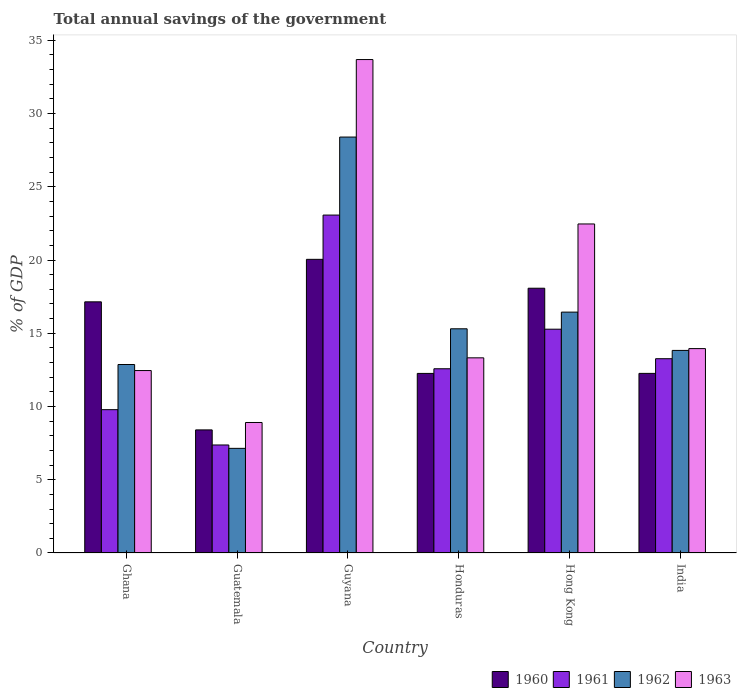How many different coloured bars are there?
Provide a short and direct response. 4. How many groups of bars are there?
Provide a short and direct response. 6. Are the number of bars on each tick of the X-axis equal?
Give a very brief answer. Yes. How many bars are there on the 6th tick from the left?
Provide a short and direct response. 4. What is the label of the 4th group of bars from the left?
Keep it short and to the point. Honduras. In how many cases, is the number of bars for a given country not equal to the number of legend labels?
Provide a short and direct response. 0. What is the total annual savings of the government in 1963 in Guyana?
Your answer should be compact. 33.69. Across all countries, what is the maximum total annual savings of the government in 1961?
Provide a short and direct response. 23.07. Across all countries, what is the minimum total annual savings of the government in 1963?
Give a very brief answer. 8.91. In which country was the total annual savings of the government in 1962 maximum?
Make the answer very short. Guyana. In which country was the total annual savings of the government in 1962 minimum?
Make the answer very short. Guatemala. What is the total total annual savings of the government in 1961 in the graph?
Your response must be concise. 81.35. What is the difference between the total annual savings of the government in 1962 in Hong Kong and that in India?
Your response must be concise. 2.61. What is the difference between the total annual savings of the government in 1963 in Hong Kong and the total annual savings of the government in 1962 in India?
Ensure brevity in your answer.  8.63. What is the average total annual savings of the government in 1963 per country?
Provide a succinct answer. 17.47. What is the difference between the total annual savings of the government of/in 1960 and total annual savings of the government of/in 1963 in Guatemala?
Provide a succinct answer. -0.51. In how many countries, is the total annual savings of the government in 1960 greater than 5 %?
Your answer should be compact. 6. What is the ratio of the total annual savings of the government in 1963 in Honduras to that in Hong Kong?
Provide a succinct answer. 0.59. Is the total annual savings of the government in 1960 in Ghana less than that in India?
Give a very brief answer. No. What is the difference between the highest and the second highest total annual savings of the government in 1960?
Provide a short and direct response. -0.93. What is the difference between the highest and the lowest total annual savings of the government in 1960?
Ensure brevity in your answer.  11.64. In how many countries, is the total annual savings of the government in 1960 greater than the average total annual savings of the government in 1960 taken over all countries?
Your response must be concise. 3. Is the sum of the total annual savings of the government in 1963 in Ghana and India greater than the maximum total annual savings of the government in 1961 across all countries?
Your response must be concise. Yes. What does the 3rd bar from the left in Honduras represents?
Your response must be concise. 1962. What does the 1st bar from the right in Hong Kong represents?
Your answer should be very brief. 1963. Is it the case that in every country, the sum of the total annual savings of the government in 1961 and total annual savings of the government in 1960 is greater than the total annual savings of the government in 1962?
Make the answer very short. Yes. How many bars are there?
Provide a succinct answer. 24. Are all the bars in the graph horizontal?
Provide a short and direct response. No. How many countries are there in the graph?
Your answer should be compact. 6. What is the difference between two consecutive major ticks on the Y-axis?
Provide a succinct answer. 5. Are the values on the major ticks of Y-axis written in scientific E-notation?
Ensure brevity in your answer.  No. Does the graph contain any zero values?
Keep it short and to the point. No. Does the graph contain grids?
Make the answer very short. No. How are the legend labels stacked?
Your answer should be very brief. Horizontal. What is the title of the graph?
Keep it short and to the point. Total annual savings of the government. Does "1989" appear as one of the legend labels in the graph?
Make the answer very short. No. What is the label or title of the X-axis?
Ensure brevity in your answer.  Country. What is the label or title of the Y-axis?
Ensure brevity in your answer.  % of GDP. What is the % of GDP in 1960 in Ghana?
Offer a terse response. 17.15. What is the % of GDP of 1961 in Ghana?
Ensure brevity in your answer.  9.78. What is the % of GDP in 1962 in Ghana?
Keep it short and to the point. 12.87. What is the % of GDP of 1963 in Ghana?
Your response must be concise. 12.45. What is the % of GDP in 1960 in Guatemala?
Your answer should be compact. 8.4. What is the % of GDP of 1961 in Guatemala?
Ensure brevity in your answer.  7.37. What is the % of GDP in 1962 in Guatemala?
Keep it short and to the point. 7.14. What is the % of GDP of 1963 in Guatemala?
Offer a very short reply. 8.91. What is the % of GDP in 1960 in Guyana?
Ensure brevity in your answer.  20.05. What is the % of GDP in 1961 in Guyana?
Your answer should be very brief. 23.07. What is the % of GDP of 1962 in Guyana?
Provide a succinct answer. 28.4. What is the % of GDP of 1963 in Guyana?
Ensure brevity in your answer.  33.69. What is the % of GDP in 1960 in Honduras?
Your answer should be compact. 12.26. What is the % of GDP in 1961 in Honduras?
Ensure brevity in your answer.  12.58. What is the % of GDP of 1962 in Honduras?
Make the answer very short. 15.31. What is the % of GDP of 1963 in Honduras?
Your answer should be very brief. 13.32. What is the % of GDP of 1960 in Hong Kong?
Provide a succinct answer. 18.07. What is the % of GDP of 1961 in Hong Kong?
Keep it short and to the point. 15.28. What is the % of GDP in 1962 in Hong Kong?
Your answer should be compact. 16.44. What is the % of GDP in 1963 in Hong Kong?
Ensure brevity in your answer.  22.46. What is the % of GDP of 1960 in India?
Offer a very short reply. 12.26. What is the % of GDP of 1961 in India?
Offer a terse response. 13.26. What is the % of GDP of 1962 in India?
Ensure brevity in your answer.  13.83. What is the % of GDP of 1963 in India?
Ensure brevity in your answer.  13.95. Across all countries, what is the maximum % of GDP of 1960?
Offer a very short reply. 20.05. Across all countries, what is the maximum % of GDP of 1961?
Make the answer very short. 23.07. Across all countries, what is the maximum % of GDP of 1962?
Make the answer very short. 28.4. Across all countries, what is the maximum % of GDP of 1963?
Offer a terse response. 33.69. Across all countries, what is the minimum % of GDP in 1960?
Provide a short and direct response. 8.4. Across all countries, what is the minimum % of GDP in 1961?
Offer a very short reply. 7.37. Across all countries, what is the minimum % of GDP in 1962?
Provide a short and direct response. 7.14. Across all countries, what is the minimum % of GDP of 1963?
Give a very brief answer. 8.91. What is the total % of GDP of 1960 in the graph?
Offer a very short reply. 88.19. What is the total % of GDP of 1961 in the graph?
Give a very brief answer. 81.35. What is the total % of GDP of 1962 in the graph?
Ensure brevity in your answer.  93.99. What is the total % of GDP of 1963 in the graph?
Your response must be concise. 104.79. What is the difference between the % of GDP in 1960 in Ghana and that in Guatemala?
Provide a short and direct response. 8.74. What is the difference between the % of GDP in 1961 in Ghana and that in Guatemala?
Make the answer very short. 2.41. What is the difference between the % of GDP in 1962 in Ghana and that in Guatemala?
Ensure brevity in your answer.  5.72. What is the difference between the % of GDP of 1963 in Ghana and that in Guatemala?
Your answer should be compact. 3.55. What is the difference between the % of GDP in 1960 in Ghana and that in Guyana?
Your answer should be very brief. -2.9. What is the difference between the % of GDP in 1961 in Ghana and that in Guyana?
Your response must be concise. -13.28. What is the difference between the % of GDP in 1962 in Ghana and that in Guyana?
Keep it short and to the point. -15.53. What is the difference between the % of GDP of 1963 in Ghana and that in Guyana?
Make the answer very short. -21.23. What is the difference between the % of GDP of 1960 in Ghana and that in Honduras?
Ensure brevity in your answer.  4.89. What is the difference between the % of GDP in 1961 in Ghana and that in Honduras?
Offer a terse response. -2.79. What is the difference between the % of GDP in 1962 in Ghana and that in Honduras?
Ensure brevity in your answer.  -2.44. What is the difference between the % of GDP of 1963 in Ghana and that in Honduras?
Your answer should be very brief. -0.87. What is the difference between the % of GDP of 1960 in Ghana and that in Hong Kong?
Your answer should be very brief. -0.93. What is the difference between the % of GDP of 1961 in Ghana and that in Hong Kong?
Give a very brief answer. -5.49. What is the difference between the % of GDP in 1962 in Ghana and that in Hong Kong?
Keep it short and to the point. -3.58. What is the difference between the % of GDP of 1963 in Ghana and that in Hong Kong?
Ensure brevity in your answer.  -10.01. What is the difference between the % of GDP of 1960 in Ghana and that in India?
Provide a short and direct response. 4.88. What is the difference between the % of GDP in 1961 in Ghana and that in India?
Offer a very short reply. -3.48. What is the difference between the % of GDP of 1962 in Ghana and that in India?
Make the answer very short. -0.96. What is the difference between the % of GDP of 1963 in Ghana and that in India?
Your answer should be very brief. -1.5. What is the difference between the % of GDP of 1960 in Guatemala and that in Guyana?
Your answer should be very brief. -11.64. What is the difference between the % of GDP of 1961 in Guatemala and that in Guyana?
Give a very brief answer. -15.7. What is the difference between the % of GDP in 1962 in Guatemala and that in Guyana?
Ensure brevity in your answer.  -21.25. What is the difference between the % of GDP in 1963 in Guatemala and that in Guyana?
Keep it short and to the point. -24.78. What is the difference between the % of GDP of 1960 in Guatemala and that in Honduras?
Your response must be concise. -3.86. What is the difference between the % of GDP of 1961 in Guatemala and that in Honduras?
Provide a short and direct response. -5.2. What is the difference between the % of GDP in 1962 in Guatemala and that in Honduras?
Offer a terse response. -8.16. What is the difference between the % of GDP of 1963 in Guatemala and that in Honduras?
Give a very brief answer. -4.41. What is the difference between the % of GDP of 1960 in Guatemala and that in Hong Kong?
Keep it short and to the point. -9.67. What is the difference between the % of GDP in 1961 in Guatemala and that in Hong Kong?
Your answer should be compact. -7.9. What is the difference between the % of GDP in 1962 in Guatemala and that in Hong Kong?
Your answer should be very brief. -9.3. What is the difference between the % of GDP in 1963 in Guatemala and that in Hong Kong?
Your response must be concise. -13.55. What is the difference between the % of GDP of 1960 in Guatemala and that in India?
Your answer should be compact. -3.86. What is the difference between the % of GDP of 1961 in Guatemala and that in India?
Ensure brevity in your answer.  -5.89. What is the difference between the % of GDP in 1962 in Guatemala and that in India?
Your answer should be very brief. -6.69. What is the difference between the % of GDP in 1963 in Guatemala and that in India?
Give a very brief answer. -5.04. What is the difference between the % of GDP in 1960 in Guyana and that in Honduras?
Make the answer very short. 7.79. What is the difference between the % of GDP of 1961 in Guyana and that in Honduras?
Give a very brief answer. 10.49. What is the difference between the % of GDP in 1962 in Guyana and that in Honduras?
Offer a terse response. 13.09. What is the difference between the % of GDP of 1963 in Guyana and that in Honduras?
Offer a very short reply. 20.36. What is the difference between the % of GDP of 1960 in Guyana and that in Hong Kong?
Make the answer very short. 1.97. What is the difference between the % of GDP of 1961 in Guyana and that in Hong Kong?
Provide a succinct answer. 7.79. What is the difference between the % of GDP in 1962 in Guyana and that in Hong Kong?
Make the answer very short. 11.95. What is the difference between the % of GDP of 1963 in Guyana and that in Hong Kong?
Make the answer very short. 11.22. What is the difference between the % of GDP of 1960 in Guyana and that in India?
Give a very brief answer. 7.79. What is the difference between the % of GDP in 1961 in Guyana and that in India?
Provide a succinct answer. 9.81. What is the difference between the % of GDP of 1962 in Guyana and that in India?
Provide a short and direct response. 14.57. What is the difference between the % of GDP in 1963 in Guyana and that in India?
Your answer should be compact. 19.73. What is the difference between the % of GDP of 1960 in Honduras and that in Hong Kong?
Offer a terse response. -5.82. What is the difference between the % of GDP of 1961 in Honduras and that in Hong Kong?
Your response must be concise. -2.7. What is the difference between the % of GDP in 1962 in Honduras and that in Hong Kong?
Ensure brevity in your answer.  -1.14. What is the difference between the % of GDP in 1963 in Honduras and that in Hong Kong?
Offer a terse response. -9.14. What is the difference between the % of GDP of 1960 in Honduras and that in India?
Offer a terse response. -0. What is the difference between the % of GDP in 1961 in Honduras and that in India?
Your answer should be compact. -0.69. What is the difference between the % of GDP in 1962 in Honduras and that in India?
Offer a very short reply. 1.48. What is the difference between the % of GDP in 1963 in Honduras and that in India?
Your answer should be very brief. -0.63. What is the difference between the % of GDP of 1960 in Hong Kong and that in India?
Provide a short and direct response. 5.81. What is the difference between the % of GDP in 1961 in Hong Kong and that in India?
Your answer should be very brief. 2.01. What is the difference between the % of GDP of 1962 in Hong Kong and that in India?
Offer a very short reply. 2.61. What is the difference between the % of GDP in 1963 in Hong Kong and that in India?
Your answer should be very brief. 8.51. What is the difference between the % of GDP in 1960 in Ghana and the % of GDP in 1961 in Guatemala?
Your response must be concise. 9.77. What is the difference between the % of GDP in 1960 in Ghana and the % of GDP in 1962 in Guatemala?
Offer a terse response. 10. What is the difference between the % of GDP in 1960 in Ghana and the % of GDP in 1963 in Guatemala?
Your answer should be very brief. 8.24. What is the difference between the % of GDP in 1961 in Ghana and the % of GDP in 1962 in Guatemala?
Provide a succinct answer. 2.64. What is the difference between the % of GDP in 1961 in Ghana and the % of GDP in 1963 in Guatemala?
Provide a short and direct response. 0.88. What is the difference between the % of GDP of 1962 in Ghana and the % of GDP of 1963 in Guatemala?
Ensure brevity in your answer.  3.96. What is the difference between the % of GDP in 1960 in Ghana and the % of GDP in 1961 in Guyana?
Keep it short and to the point. -5.92. What is the difference between the % of GDP of 1960 in Ghana and the % of GDP of 1962 in Guyana?
Your response must be concise. -11.25. What is the difference between the % of GDP in 1960 in Ghana and the % of GDP in 1963 in Guyana?
Provide a short and direct response. -16.54. What is the difference between the % of GDP in 1961 in Ghana and the % of GDP in 1962 in Guyana?
Your response must be concise. -18.61. What is the difference between the % of GDP of 1961 in Ghana and the % of GDP of 1963 in Guyana?
Offer a terse response. -23.9. What is the difference between the % of GDP of 1962 in Ghana and the % of GDP of 1963 in Guyana?
Your answer should be very brief. -20.82. What is the difference between the % of GDP of 1960 in Ghana and the % of GDP of 1961 in Honduras?
Offer a very short reply. 4.57. What is the difference between the % of GDP in 1960 in Ghana and the % of GDP in 1962 in Honduras?
Your answer should be very brief. 1.84. What is the difference between the % of GDP in 1960 in Ghana and the % of GDP in 1963 in Honduras?
Keep it short and to the point. 3.82. What is the difference between the % of GDP in 1961 in Ghana and the % of GDP in 1962 in Honduras?
Keep it short and to the point. -5.52. What is the difference between the % of GDP of 1961 in Ghana and the % of GDP of 1963 in Honduras?
Provide a succinct answer. -3.54. What is the difference between the % of GDP in 1962 in Ghana and the % of GDP in 1963 in Honduras?
Provide a short and direct response. -0.46. What is the difference between the % of GDP in 1960 in Ghana and the % of GDP in 1961 in Hong Kong?
Give a very brief answer. 1.87. What is the difference between the % of GDP of 1960 in Ghana and the % of GDP of 1962 in Hong Kong?
Offer a very short reply. 0.7. What is the difference between the % of GDP of 1960 in Ghana and the % of GDP of 1963 in Hong Kong?
Provide a succinct answer. -5.32. What is the difference between the % of GDP of 1961 in Ghana and the % of GDP of 1962 in Hong Kong?
Provide a short and direct response. -6.66. What is the difference between the % of GDP in 1961 in Ghana and the % of GDP in 1963 in Hong Kong?
Offer a very short reply. -12.68. What is the difference between the % of GDP in 1962 in Ghana and the % of GDP in 1963 in Hong Kong?
Ensure brevity in your answer.  -9.6. What is the difference between the % of GDP in 1960 in Ghana and the % of GDP in 1961 in India?
Provide a short and direct response. 3.88. What is the difference between the % of GDP of 1960 in Ghana and the % of GDP of 1962 in India?
Provide a short and direct response. 3.32. What is the difference between the % of GDP in 1960 in Ghana and the % of GDP in 1963 in India?
Offer a terse response. 3.19. What is the difference between the % of GDP in 1961 in Ghana and the % of GDP in 1962 in India?
Offer a terse response. -4.05. What is the difference between the % of GDP of 1961 in Ghana and the % of GDP of 1963 in India?
Your answer should be compact. -4.17. What is the difference between the % of GDP of 1962 in Ghana and the % of GDP of 1963 in India?
Your answer should be very brief. -1.09. What is the difference between the % of GDP of 1960 in Guatemala and the % of GDP of 1961 in Guyana?
Ensure brevity in your answer.  -14.67. What is the difference between the % of GDP of 1960 in Guatemala and the % of GDP of 1962 in Guyana?
Ensure brevity in your answer.  -19.99. What is the difference between the % of GDP in 1960 in Guatemala and the % of GDP in 1963 in Guyana?
Ensure brevity in your answer.  -25.28. What is the difference between the % of GDP of 1961 in Guatemala and the % of GDP of 1962 in Guyana?
Give a very brief answer. -21.02. What is the difference between the % of GDP in 1961 in Guatemala and the % of GDP in 1963 in Guyana?
Your answer should be compact. -26.31. What is the difference between the % of GDP of 1962 in Guatemala and the % of GDP of 1963 in Guyana?
Keep it short and to the point. -26.54. What is the difference between the % of GDP of 1960 in Guatemala and the % of GDP of 1961 in Honduras?
Provide a succinct answer. -4.17. What is the difference between the % of GDP of 1960 in Guatemala and the % of GDP of 1962 in Honduras?
Provide a short and direct response. -6.9. What is the difference between the % of GDP of 1960 in Guatemala and the % of GDP of 1963 in Honduras?
Your answer should be compact. -4.92. What is the difference between the % of GDP of 1961 in Guatemala and the % of GDP of 1962 in Honduras?
Your answer should be very brief. -7.93. What is the difference between the % of GDP of 1961 in Guatemala and the % of GDP of 1963 in Honduras?
Offer a very short reply. -5.95. What is the difference between the % of GDP in 1962 in Guatemala and the % of GDP in 1963 in Honduras?
Make the answer very short. -6.18. What is the difference between the % of GDP in 1960 in Guatemala and the % of GDP in 1961 in Hong Kong?
Provide a succinct answer. -6.87. What is the difference between the % of GDP in 1960 in Guatemala and the % of GDP in 1962 in Hong Kong?
Provide a succinct answer. -8.04. What is the difference between the % of GDP of 1960 in Guatemala and the % of GDP of 1963 in Hong Kong?
Ensure brevity in your answer.  -14.06. What is the difference between the % of GDP in 1961 in Guatemala and the % of GDP in 1962 in Hong Kong?
Your answer should be very brief. -9.07. What is the difference between the % of GDP in 1961 in Guatemala and the % of GDP in 1963 in Hong Kong?
Provide a succinct answer. -15.09. What is the difference between the % of GDP in 1962 in Guatemala and the % of GDP in 1963 in Hong Kong?
Offer a terse response. -15.32. What is the difference between the % of GDP of 1960 in Guatemala and the % of GDP of 1961 in India?
Provide a succinct answer. -4.86. What is the difference between the % of GDP of 1960 in Guatemala and the % of GDP of 1962 in India?
Your answer should be very brief. -5.43. What is the difference between the % of GDP of 1960 in Guatemala and the % of GDP of 1963 in India?
Provide a succinct answer. -5.55. What is the difference between the % of GDP of 1961 in Guatemala and the % of GDP of 1962 in India?
Give a very brief answer. -6.46. What is the difference between the % of GDP of 1961 in Guatemala and the % of GDP of 1963 in India?
Your response must be concise. -6.58. What is the difference between the % of GDP of 1962 in Guatemala and the % of GDP of 1963 in India?
Your response must be concise. -6.81. What is the difference between the % of GDP in 1960 in Guyana and the % of GDP in 1961 in Honduras?
Your answer should be very brief. 7.47. What is the difference between the % of GDP of 1960 in Guyana and the % of GDP of 1962 in Honduras?
Provide a succinct answer. 4.74. What is the difference between the % of GDP in 1960 in Guyana and the % of GDP in 1963 in Honduras?
Your response must be concise. 6.73. What is the difference between the % of GDP of 1961 in Guyana and the % of GDP of 1962 in Honduras?
Make the answer very short. 7.76. What is the difference between the % of GDP of 1961 in Guyana and the % of GDP of 1963 in Honduras?
Offer a terse response. 9.75. What is the difference between the % of GDP of 1962 in Guyana and the % of GDP of 1963 in Honduras?
Your response must be concise. 15.07. What is the difference between the % of GDP in 1960 in Guyana and the % of GDP in 1961 in Hong Kong?
Offer a terse response. 4.77. What is the difference between the % of GDP in 1960 in Guyana and the % of GDP in 1962 in Hong Kong?
Your answer should be compact. 3.6. What is the difference between the % of GDP of 1960 in Guyana and the % of GDP of 1963 in Hong Kong?
Your answer should be compact. -2.42. What is the difference between the % of GDP in 1961 in Guyana and the % of GDP in 1962 in Hong Kong?
Keep it short and to the point. 6.63. What is the difference between the % of GDP of 1961 in Guyana and the % of GDP of 1963 in Hong Kong?
Provide a short and direct response. 0.61. What is the difference between the % of GDP of 1962 in Guyana and the % of GDP of 1963 in Hong Kong?
Offer a very short reply. 5.93. What is the difference between the % of GDP of 1960 in Guyana and the % of GDP of 1961 in India?
Make the answer very short. 6.78. What is the difference between the % of GDP in 1960 in Guyana and the % of GDP in 1962 in India?
Provide a succinct answer. 6.22. What is the difference between the % of GDP of 1960 in Guyana and the % of GDP of 1963 in India?
Offer a terse response. 6.09. What is the difference between the % of GDP of 1961 in Guyana and the % of GDP of 1962 in India?
Make the answer very short. 9.24. What is the difference between the % of GDP of 1961 in Guyana and the % of GDP of 1963 in India?
Your response must be concise. 9.12. What is the difference between the % of GDP of 1962 in Guyana and the % of GDP of 1963 in India?
Your response must be concise. 14.44. What is the difference between the % of GDP of 1960 in Honduras and the % of GDP of 1961 in Hong Kong?
Ensure brevity in your answer.  -3.02. What is the difference between the % of GDP in 1960 in Honduras and the % of GDP in 1962 in Hong Kong?
Keep it short and to the point. -4.18. What is the difference between the % of GDP in 1960 in Honduras and the % of GDP in 1963 in Hong Kong?
Your answer should be compact. -10.2. What is the difference between the % of GDP of 1961 in Honduras and the % of GDP of 1962 in Hong Kong?
Provide a short and direct response. -3.87. What is the difference between the % of GDP of 1961 in Honduras and the % of GDP of 1963 in Hong Kong?
Make the answer very short. -9.89. What is the difference between the % of GDP in 1962 in Honduras and the % of GDP in 1963 in Hong Kong?
Your answer should be very brief. -7.16. What is the difference between the % of GDP of 1960 in Honduras and the % of GDP of 1961 in India?
Ensure brevity in your answer.  -1. What is the difference between the % of GDP of 1960 in Honduras and the % of GDP of 1962 in India?
Keep it short and to the point. -1.57. What is the difference between the % of GDP in 1960 in Honduras and the % of GDP in 1963 in India?
Your answer should be compact. -1.69. What is the difference between the % of GDP of 1961 in Honduras and the % of GDP of 1962 in India?
Make the answer very short. -1.25. What is the difference between the % of GDP of 1961 in Honduras and the % of GDP of 1963 in India?
Provide a succinct answer. -1.38. What is the difference between the % of GDP of 1962 in Honduras and the % of GDP of 1963 in India?
Provide a succinct answer. 1.35. What is the difference between the % of GDP of 1960 in Hong Kong and the % of GDP of 1961 in India?
Your answer should be compact. 4.81. What is the difference between the % of GDP in 1960 in Hong Kong and the % of GDP in 1962 in India?
Give a very brief answer. 4.24. What is the difference between the % of GDP of 1960 in Hong Kong and the % of GDP of 1963 in India?
Your answer should be compact. 4.12. What is the difference between the % of GDP in 1961 in Hong Kong and the % of GDP in 1962 in India?
Give a very brief answer. 1.45. What is the difference between the % of GDP in 1961 in Hong Kong and the % of GDP in 1963 in India?
Ensure brevity in your answer.  1.32. What is the difference between the % of GDP in 1962 in Hong Kong and the % of GDP in 1963 in India?
Your answer should be compact. 2.49. What is the average % of GDP of 1960 per country?
Your response must be concise. 14.7. What is the average % of GDP of 1961 per country?
Your answer should be compact. 13.56. What is the average % of GDP of 1962 per country?
Keep it short and to the point. 15.66. What is the average % of GDP of 1963 per country?
Keep it short and to the point. 17.46. What is the difference between the % of GDP in 1960 and % of GDP in 1961 in Ghana?
Your answer should be very brief. 7.36. What is the difference between the % of GDP of 1960 and % of GDP of 1962 in Ghana?
Give a very brief answer. 4.28. What is the difference between the % of GDP of 1960 and % of GDP of 1963 in Ghana?
Keep it short and to the point. 4.69. What is the difference between the % of GDP of 1961 and % of GDP of 1962 in Ghana?
Provide a short and direct response. -3.08. What is the difference between the % of GDP of 1961 and % of GDP of 1963 in Ghana?
Provide a succinct answer. -2.67. What is the difference between the % of GDP in 1962 and % of GDP in 1963 in Ghana?
Make the answer very short. 0.41. What is the difference between the % of GDP of 1960 and % of GDP of 1961 in Guatemala?
Offer a very short reply. 1.03. What is the difference between the % of GDP in 1960 and % of GDP in 1962 in Guatemala?
Offer a very short reply. 1.26. What is the difference between the % of GDP in 1960 and % of GDP in 1963 in Guatemala?
Your response must be concise. -0.51. What is the difference between the % of GDP of 1961 and % of GDP of 1962 in Guatemala?
Provide a succinct answer. 0.23. What is the difference between the % of GDP in 1961 and % of GDP in 1963 in Guatemala?
Keep it short and to the point. -1.53. What is the difference between the % of GDP in 1962 and % of GDP in 1963 in Guatemala?
Your answer should be very brief. -1.76. What is the difference between the % of GDP in 1960 and % of GDP in 1961 in Guyana?
Your answer should be compact. -3.02. What is the difference between the % of GDP in 1960 and % of GDP in 1962 in Guyana?
Give a very brief answer. -8.35. What is the difference between the % of GDP in 1960 and % of GDP in 1963 in Guyana?
Give a very brief answer. -13.64. What is the difference between the % of GDP in 1961 and % of GDP in 1962 in Guyana?
Your answer should be compact. -5.33. What is the difference between the % of GDP in 1961 and % of GDP in 1963 in Guyana?
Ensure brevity in your answer.  -10.62. What is the difference between the % of GDP of 1962 and % of GDP of 1963 in Guyana?
Your answer should be very brief. -5.29. What is the difference between the % of GDP of 1960 and % of GDP of 1961 in Honduras?
Your answer should be very brief. -0.32. What is the difference between the % of GDP in 1960 and % of GDP in 1962 in Honduras?
Provide a succinct answer. -3.05. What is the difference between the % of GDP of 1960 and % of GDP of 1963 in Honduras?
Give a very brief answer. -1.06. What is the difference between the % of GDP in 1961 and % of GDP in 1962 in Honduras?
Give a very brief answer. -2.73. What is the difference between the % of GDP in 1961 and % of GDP in 1963 in Honduras?
Your response must be concise. -0.75. What is the difference between the % of GDP of 1962 and % of GDP of 1963 in Honduras?
Make the answer very short. 1.98. What is the difference between the % of GDP in 1960 and % of GDP in 1961 in Hong Kong?
Ensure brevity in your answer.  2.8. What is the difference between the % of GDP in 1960 and % of GDP in 1962 in Hong Kong?
Give a very brief answer. 1.63. What is the difference between the % of GDP in 1960 and % of GDP in 1963 in Hong Kong?
Offer a terse response. -4.39. What is the difference between the % of GDP of 1961 and % of GDP of 1962 in Hong Kong?
Your answer should be very brief. -1.17. What is the difference between the % of GDP in 1961 and % of GDP in 1963 in Hong Kong?
Your answer should be compact. -7.19. What is the difference between the % of GDP of 1962 and % of GDP of 1963 in Hong Kong?
Give a very brief answer. -6.02. What is the difference between the % of GDP of 1960 and % of GDP of 1961 in India?
Give a very brief answer. -1. What is the difference between the % of GDP in 1960 and % of GDP in 1962 in India?
Your answer should be very brief. -1.57. What is the difference between the % of GDP of 1960 and % of GDP of 1963 in India?
Your answer should be very brief. -1.69. What is the difference between the % of GDP of 1961 and % of GDP of 1962 in India?
Offer a terse response. -0.57. What is the difference between the % of GDP of 1961 and % of GDP of 1963 in India?
Make the answer very short. -0.69. What is the difference between the % of GDP in 1962 and % of GDP in 1963 in India?
Your response must be concise. -0.12. What is the ratio of the % of GDP in 1960 in Ghana to that in Guatemala?
Offer a terse response. 2.04. What is the ratio of the % of GDP of 1961 in Ghana to that in Guatemala?
Your answer should be compact. 1.33. What is the ratio of the % of GDP of 1962 in Ghana to that in Guatemala?
Your answer should be very brief. 1.8. What is the ratio of the % of GDP of 1963 in Ghana to that in Guatemala?
Your answer should be compact. 1.4. What is the ratio of the % of GDP in 1960 in Ghana to that in Guyana?
Make the answer very short. 0.86. What is the ratio of the % of GDP of 1961 in Ghana to that in Guyana?
Your answer should be compact. 0.42. What is the ratio of the % of GDP in 1962 in Ghana to that in Guyana?
Offer a very short reply. 0.45. What is the ratio of the % of GDP in 1963 in Ghana to that in Guyana?
Make the answer very short. 0.37. What is the ratio of the % of GDP of 1960 in Ghana to that in Honduras?
Ensure brevity in your answer.  1.4. What is the ratio of the % of GDP of 1961 in Ghana to that in Honduras?
Make the answer very short. 0.78. What is the ratio of the % of GDP in 1962 in Ghana to that in Honduras?
Offer a very short reply. 0.84. What is the ratio of the % of GDP of 1963 in Ghana to that in Honduras?
Your answer should be very brief. 0.93. What is the ratio of the % of GDP of 1960 in Ghana to that in Hong Kong?
Your response must be concise. 0.95. What is the ratio of the % of GDP of 1961 in Ghana to that in Hong Kong?
Make the answer very short. 0.64. What is the ratio of the % of GDP of 1962 in Ghana to that in Hong Kong?
Your answer should be very brief. 0.78. What is the ratio of the % of GDP in 1963 in Ghana to that in Hong Kong?
Your answer should be very brief. 0.55. What is the ratio of the % of GDP of 1960 in Ghana to that in India?
Your response must be concise. 1.4. What is the ratio of the % of GDP of 1961 in Ghana to that in India?
Offer a terse response. 0.74. What is the ratio of the % of GDP of 1962 in Ghana to that in India?
Your answer should be very brief. 0.93. What is the ratio of the % of GDP in 1963 in Ghana to that in India?
Give a very brief answer. 0.89. What is the ratio of the % of GDP of 1960 in Guatemala to that in Guyana?
Keep it short and to the point. 0.42. What is the ratio of the % of GDP of 1961 in Guatemala to that in Guyana?
Your answer should be compact. 0.32. What is the ratio of the % of GDP of 1962 in Guatemala to that in Guyana?
Give a very brief answer. 0.25. What is the ratio of the % of GDP in 1963 in Guatemala to that in Guyana?
Make the answer very short. 0.26. What is the ratio of the % of GDP of 1960 in Guatemala to that in Honduras?
Provide a succinct answer. 0.69. What is the ratio of the % of GDP of 1961 in Guatemala to that in Honduras?
Ensure brevity in your answer.  0.59. What is the ratio of the % of GDP of 1962 in Guatemala to that in Honduras?
Your response must be concise. 0.47. What is the ratio of the % of GDP in 1963 in Guatemala to that in Honduras?
Keep it short and to the point. 0.67. What is the ratio of the % of GDP in 1960 in Guatemala to that in Hong Kong?
Your answer should be compact. 0.46. What is the ratio of the % of GDP in 1961 in Guatemala to that in Hong Kong?
Offer a terse response. 0.48. What is the ratio of the % of GDP in 1962 in Guatemala to that in Hong Kong?
Provide a succinct answer. 0.43. What is the ratio of the % of GDP of 1963 in Guatemala to that in Hong Kong?
Your answer should be very brief. 0.4. What is the ratio of the % of GDP of 1960 in Guatemala to that in India?
Offer a terse response. 0.69. What is the ratio of the % of GDP of 1961 in Guatemala to that in India?
Your response must be concise. 0.56. What is the ratio of the % of GDP of 1962 in Guatemala to that in India?
Provide a short and direct response. 0.52. What is the ratio of the % of GDP in 1963 in Guatemala to that in India?
Provide a short and direct response. 0.64. What is the ratio of the % of GDP in 1960 in Guyana to that in Honduras?
Offer a terse response. 1.64. What is the ratio of the % of GDP of 1961 in Guyana to that in Honduras?
Provide a short and direct response. 1.83. What is the ratio of the % of GDP of 1962 in Guyana to that in Honduras?
Your answer should be compact. 1.86. What is the ratio of the % of GDP in 1963 in Guyana to that in Honduras?
Provide a short and direct response. 2.53. What is the ratio of the % of GDP of 1960 in Guyana to that in Hong Kong?
Give a very brief answer. 1.11. What is the ratio of the % of GDP of 1961 in Guyana to that in Hong Kong?
Provide a succinct answer. 1.51. What is the ratio of the % of GDP of 1962 in Guyana to that in Hong Kong?
Ensure brevity in your answer.  1.73. What is the ratio of the % of GDP in 1963 in Guyana to that in Hong Kong?
Your answer should be compact. 1.5. What is the ratio of the % of GDP of 1960 in Guyana to that in India?
Offer a terse response. 1.64. What is the ratio of the % of GDP of 1961 in Guyana to that in India?
Your answer should be very brief. 1.74. What is the ratio of the % of GDP of 1962 in Guyana to that in India?
Provide a succinct answer. 2.05. What is the ratio of the % of GDP in 1963 in Guyana to that in India?
Make the answer very short. 2.41. What is the ratio of the % of GDP in 1960 in Honduras to that in Hong Kong?
Provide a succinct answer. 0.68. What is the ratio of the % of GDP in 1961 in Honduras to that in Hong Kong?
Keep it short and to the point. 0.82. What is the ratio of the % of GDP of 1962 in Honduras to that in Hong Kong?
Your answer should be very brief. 0.93. What is the ratio of the % of GDP in 1963 in Honduras to that in Hong Kong?
Your response must be concise. 0.59. What is the ratio of the % of GDP of 1961 in Honduras to that in India?
Offer a terse response. 0.95. What is the ratio of the % of GDP in 1962 in Honduras to that in India?
Your response must be concise. 1.11. What is the ratio of the % of GDP of 1963 in Honduras to that in India?
Your answer should be very brief. 0.95. What is the ratio of the % of GDP of 1960 in Hong Kong to that in India?
Offer a very short reply. 1.47. What is the ratio of the % of GDP of 1961 in Hong Kong to that in India?
Your answer should be compact. 1.15. What is the ratio of the % of GDP of 1962 in Hong Kong to that in India?
Your answer should be very brief. 1.19. What is the ratio of the % of GDP in 1963 in Hong Kong to that in India?
Ensure brevity in your answer.  1.61. What is the difference between the highest and the second highest % of GDP in 1960?
Give a very brief answer. 1.97. What is the difference between the highest and the second highest % of GDP in 1961?
Your response must be concise. 7.79. What is the difference between the highest and the second highest % of GDP of 1962?
Make the answer very short. 11.95. What is the difference between the highest and the second highest % of GDP in 1963?
Keep it short and to the point. 11.22. What is the difference between the highest and the lowest % of GDP in 1960?
Give a very brief answer. 11.64. What is the difference between the highest and the lowest % of GDP of 1961?
Offer a very short reply. 15.7. What is the difference between the highest and the lowest % of GDP in 1962?
Ensure brevity in your answer.  21.25. What is the difference between the highest and the lowest % of GDP of 1963?
Your answer should be compact. 24.78. 